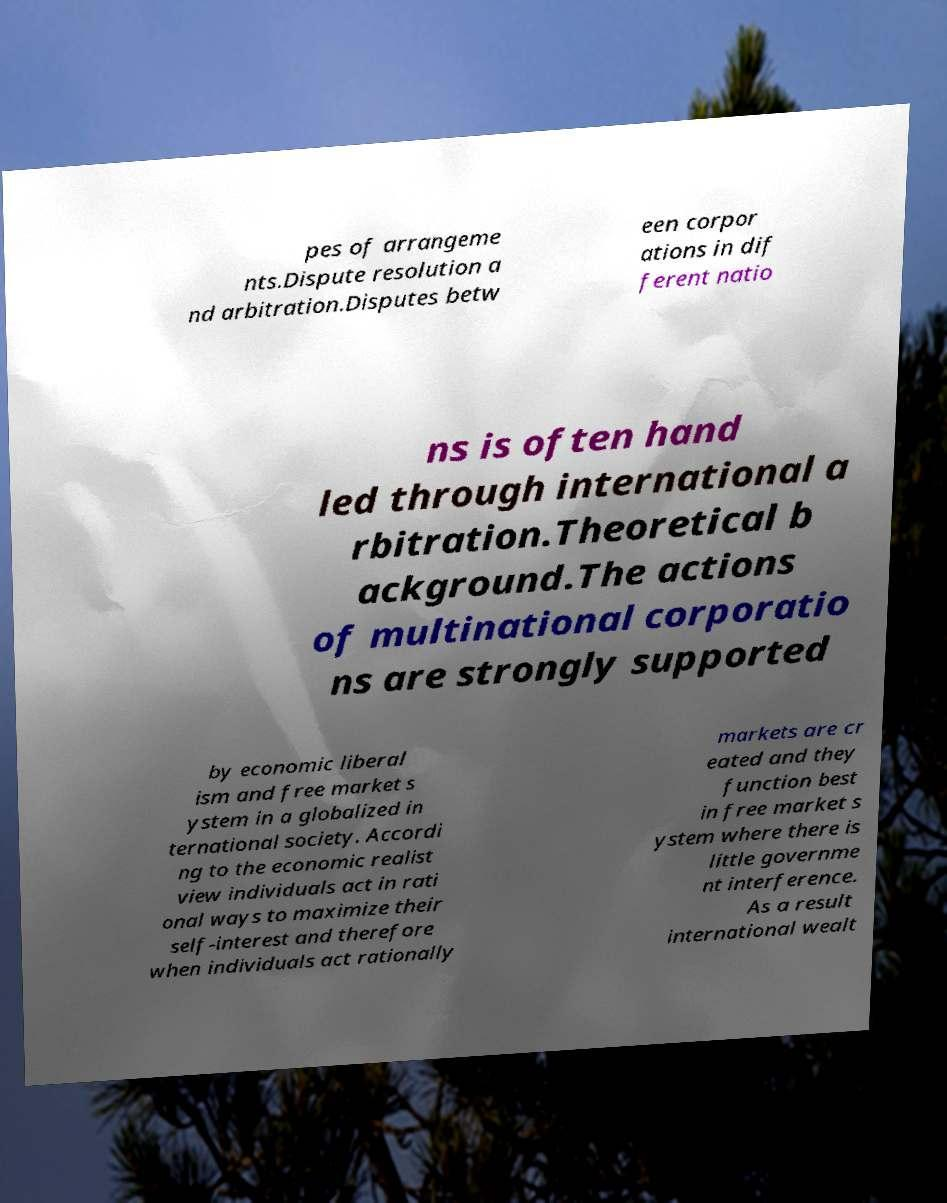I need the written content from this picture converted into text. Can you do that? pes of arrangeme nts.Dispute resolution a nd arbitration.Disputes betw een corpor ations in dif ferent natio ns is often hand led through international a rbitration.Theoretical b ackground.The actions of multinational corporatio ns are strongly supported by economic liberal ism and free market s ystem in a globalized in ternational society. Accordi ng to the economic realist view individuals act in rati onal ways to maximize their self-interest and therefore when individuals act rationally markets are cr eated and they function best in free market s ystem where there is little governme nt interference. As a result international wealt 